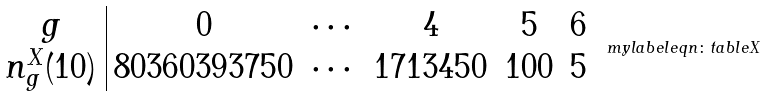<formula> <loc_0><loc_0><loc_500><loc_500>\begin{array} { c | c c c c c } g & 0 & \cdots & 4 & 5 & 6 \\ n _ { g } ^ { X } ( 1 0 ) & 8 0 3 6 0 3 9 3 7 5 0 & \cdots & 1 7 1 3 4 5 0 & 1 0 0 & 5 \\ \end{array} \ m y l a b e l { e q n \colon t a b l e X }</formula> 